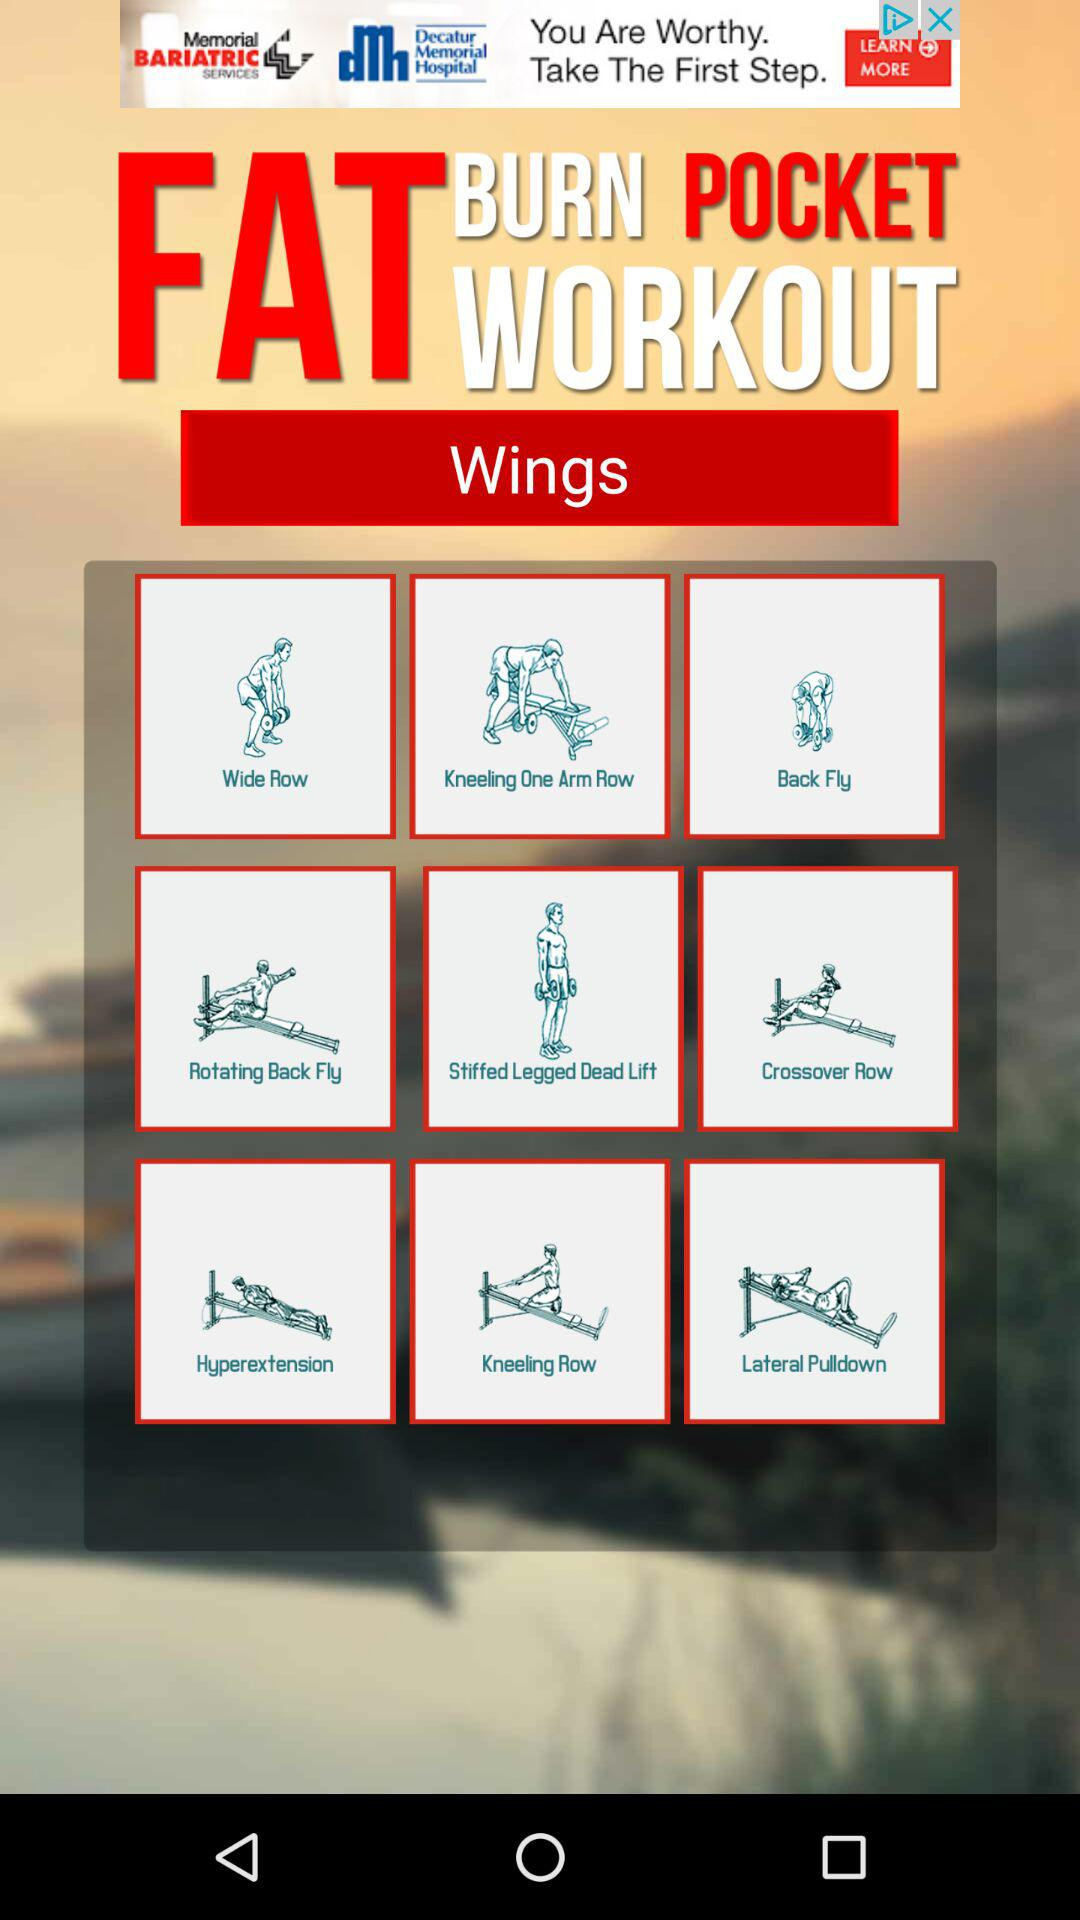For what part of the body is the workout intended? The workout is intended for wings. 